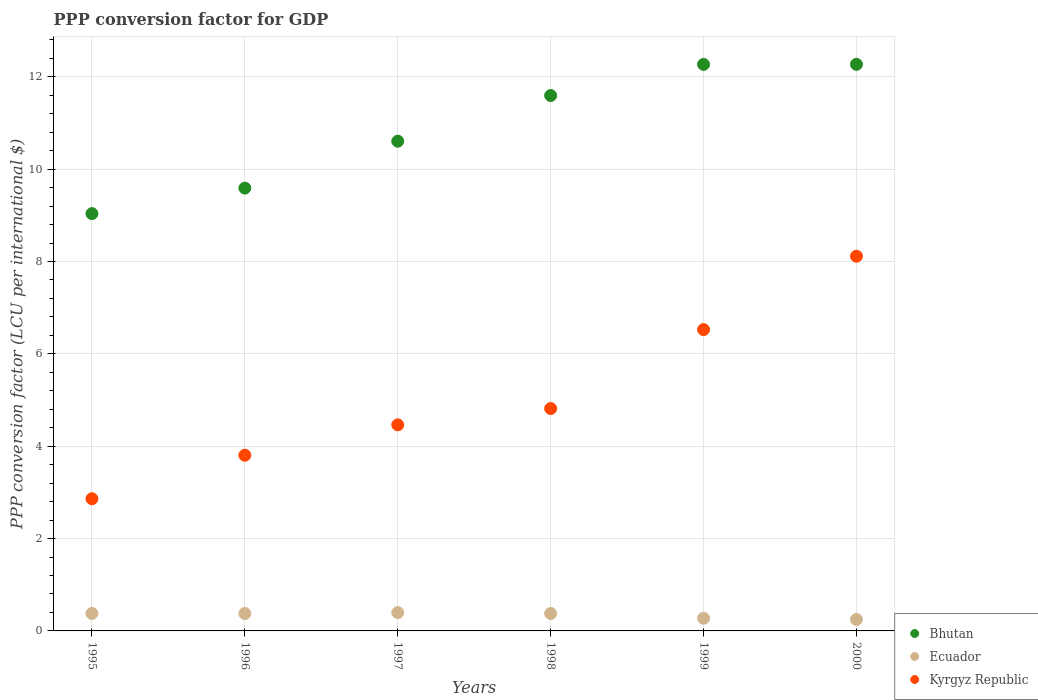What is the PPP conversion factor for GDP in Ecuador in 1999?
Provide a short and direct response. 0.27. Across all years, what is the maximum PPP conversion factor for GDP in Ecuador?
Provide a short and direct response. 0.4. Across all years, what is the minimum PPP conversion factor for GDP in Ecuador?
Ensure brevity in your answer.  0.25. What is the total PPP conversion factor for GDP in Ecuador in the graph?
Give a very brief answer. 2.05. What is the difference between the PPP conversion factor for GDP in Bhutan in 1996 and that in 2000?
Keep it short and to the point. -2.68. What is the difference between the PPP conversion factor for GDP in Kyrgyz Republic in 1995 and the PPP conversion factor for GDP in Ecuador in 1999?
Make the answer very short. 2.59. What is the average PPP conversion factor for GDP in Ecuador per year?
Your answer should be compact. 0.34. In the year 1996, what is the difference between the PPP conversion factor for GDP in Bhutan and PPP conversion factor for GDP in Ecuador?
Your answer should be compact. 9.21. What is the ratio of the PPP conversion factor for GDP in Ecuador in 1997 to that in 1998?
Provide a succinct answer. 1.05. Is the difference between the PPP conversion factor for GDP in Bhutan in 1999 and 2000 greater than the difference between the PPP conversion factor for GDP in Ecuador in 1999 and 2000?
Offer a terse response. No. What is the difference between the highest and the second highest PPP conversion factor for GDP in Ecuador?
Your response must be concise. 0.02. What is the difference between the highest and the lowest PPP conversion factor for GDP in Ecuador?
Your answer should be very brief. 0.15. Is the sum of the PPP conversion factor for GDP in Kyrgyz Republic in 1995 and 1996 greater than the maximum PPP conversion factor for GDP in Ecuador across all years?
Provide a succinct answer. Yes. Is it the case that in every year, the sum of the PPP conversion factor for GDP in Bhutan and PPP conversion factor for GDP in Ecuador  is greater than the PPP conversion factor for GDP in Kyrgyz Republic?
Offer a terse response. Yes. Does the PPP conversion factor for GDP in Ecuador monotonically increase over the years?
Your answer should be very brief. No. Is the PPP conversion factor for GDP in Bhutan strictly greater than the PPP conversion factor for GDP in Ecuador over the years?
Keep it short and to the point. Yes. Is the PPP conversion factor for GDP in Kyrgyz Republic strictly less than the PPP conversion factor for GDP in Ecuador over the years?
Give a very brief answer. No. How many dotlines are there?
Your answer should be very brief. 3. What is the difference between two consecutive major ticks on the Y-axis?
Keep it short and to the point. 2. Does the graph contain any zero values?
Provide a short and direct response. No. Where does the legend appear in the graph?
Provide a short and direct response. Bottom right. How many legend labels are there?
Ensure brevity in your answer.  3. How are the legend labels stacked?
Your response must be concise. Vertical. What is the title of the graph?
Provide a short and direct response. PPP conversion factor for GDP. What is the label or title of the Y-axis?
Provide a short and direct response. PPP conversion factor (LCU per international $). What is the PPP conversion factor (LCU per international $) of Bhutan in 1995?
Your answer should be very brief. 9.04. What is the PPP conversion factor (LCU per international $) of Ecuador in 1995?
Offer a very short reply. 0.38. What is the PPP conversion factor (LCU per international $) of Kyrgyz Republic in 1995?
Offer a very short reply. 2.86. What is the PPP conversion factor (LCU per international $) of Bhutan in 1996?
Make the answer very short. 9.59. What is the PPP conversion factor (LCU per international $) in Ecuador in 1996?
Provide a short and direct response. 0.38. What is the PPP conversion factor (LCU per international $) of Kyrgyz Republic in 1996?
Your answer should be compact. 3.8. What is the PPP conversion factor (LCU per international $) in Bhutan in 1997?
Make the answer very short. 10.61. What is the PPP conversion factor (LCU per international $) of Ecuador in 1997?
Keep it short and to the point. 0.4. What is the PPP conversion factor (LCU per international $) of Kyrgyz Republic in 1997?
Give a very brief answer. 4.46. What is the PPP conversion factor (LCU per international $) in Bhutan in 1998?
Keep it short and to the point. 11.59. What is the PPP conversion factor (LCU per international $) in Ecuador in 1998?
Offer a terse response. 0.38. What is the PPP conversion factor (LCU per international $) in Kyrgyz Republic in 1998?
Offer a very short reply. 4.82. What is the PPP conversion factor (LCU per international $) of Bhutan in 1999?
Offer a very short reply. 12.27. What is the PPP conversion factor (LCU per international $) of Ecuador in 1999?
Keep it short and to the point. 0.27. What is the PPP conversion factor (LCU per international $) of Kyrgyz Republic in 1999?
Provide a succinct answer. 6.53. What is the PPP conversion factor (LCU per international $) of Bhutan in 2000?
Offer a terse response. 12.27. What is the PPP conversion factor (LCU per international $) in Ecuador in 2000?
Give a very brief answer. 0.25. What is the PPP conversion factor (LCU per international $) in Kyrgyz Republic in 2000?
Keep it short and to the point. 8.11. Across all years, what is the maximum PPP conversion factor (LCU per international $) in Bhutan?
Provide a short and direct response. 12.27. Across all years, what is the maximum PPP conversion factor (LCU per international $) in Ecuador?
Your answer should be compact. 0.4. Across all years, what is the maximum PPP conversion factor (LCU per international $) of Kyrgyz Republic?
Keep it short and to the point. 8.11. Across all years, what is the minimum PPP conversion factor (LCU per international $) of Bhutan?
Provide a short and direct response. 9.04. Across all years, what is the minimum PPP conversion factor (LCU per international $) in Ecuador?
Make the answer very short. 0.25. Across all years, what is the minimum PPP conversion factor (LCU per international $) in Kyrgyz Republic?
Your answer should be very brief. 2.86. What is the total PPP conversion factor (LCU per international $) in Bhutan in the graph?
Your answer should be compact. 65.37. What is the total PPP conversion factor (LCU per international $) in Ecuador in the graph?
Give a very brief answer. 2.05. What is the total PPP conversion factor (LCU per international $) in Kyrgyz Republic in the graph?
Keep it short and to the point. 30.59. What is the difference between the PPP conversion factor (LCU per international $) in Bhutan in 1995 and that in 1996?
Provide a short and direct response. -0.55. What is the difference between the PPP conversion factor (LCU per international $) in Ecuador in 1995 and that in 1996?
Your answer should be very brief. 0. What is the difference between the PPP conversion factor (LCU per international $) in Kyrgyz Republic in 1995 and that in 1996?
Offer a very short reply. -0.94. What is the difference between the PPP conversion factor (LCU per international $) of Bhutan in 1995 and that in 1997?
Your answer should be compact. -1.57. What is the difference between the PPP conversion factor (LCU per international $) of Ecuador in 1995 and that in 1997?
Your answer should be very brief. -0.02. What is the difference between the PPP conversion factor (LCU per international $) in Kyrgyz Republic in 1995 and that in 1997?
Your answer should be compact. -1.6. What is the difference between the PPP conversion factor (LCU per international $) of Bhutan in 1995 and that in 1998?
Provide a succinct answer. -2.56. What is the difference between the PPP conversion factor (LCU per international $) of Ecuador in 1995 and that in 1998?
Provide a short and direct response. 0. What is the difference between the PPP conversion factor (LCU per international $) of Kyrgyz Republic in 1995 and that in 1998?
Give a very brief answer. -1.95. What is the difference between the PPP conversion factor (LCU per international $) of Bhutan in 1995 and that in 1999?
Your answer should be very brief. -3.23. What is the difference between the PPP conversion factor (LCU per international $) in Ecuador in 1995 and that in 1999?
Your response must be concise. 0.1. What is the difference between the PPP conversion factor (LCU per international $) of Kyrgyz Republic in 1995 and that in 1999?
Keep it short and to the point. -3.66. What is the difference between the PPP conversion factor (LCU per international $) of Bhutan in 1995 and that in 2000?
Your response must be concise. -3.23. What is the difference between the PPP conversion factor (LCU per international $) in Ecuador in 1995 and that in 2000?
Offer a terse response. 0.13. What is the difference between the PPP conversion factor (LCU per international $) in Kyrgyz Republic in 1995 and that in 2000?
Keep it short and to the point. -5.25. What is the difference between the PPP conversion factor (LCU per international $) in Bhutan in 1996 and that in 1997?
Keep it short and to the point. -1.02. What is the difference between the PPP conversion factor (LCU per international $) of Ecuador in 1996 and that in 1997?
Ensure brevity in your answer.  -0.02. What is the difference between the PPP conversion factor (LCU per international $) of Kyrgyz Republic in 1996 and that in 1997?
Provide a succinct answer. -0.66. What is the difference between the PPP conversion factor (LCU per international $) of Bhutan in 1996 and that in 1998?
Make the answer very short. -2. What is the difference between the PPP conversion factor (LCU per international $) in Ecuador in 1996 and that in 1998?
Your response must be concise. -0. What is the difference between the PPP conversion factor (LCU per international $) of Kyrgyz Republic in 1996 and that in 1998?
Make the answer very short. -1.01. What is the difference between the PPP conversion factor (LCU per international $) in Bhutan in 1996 and that in 1999?
Offer a terse response. -2.68. What is the difference between the PPP conversion factor (LCU per international $) of Ecuador in 1996 and that in 1999?
Provide a succinct answer. 0.1. What is the difference between the PPP conversion factor (LCU per international $) in Kyrgyz Republic in 1996 and that in 1999?
Provide a succinct answer. -2.72. What is the difference between the PPP conversion factor (LCU per international $) in Bhutan in 1996 and that in 2000?
Keep it short and to the point. -2.68. What is the difference between the PPP conversion factor (LCU per international $) of Ecuador in 1996 and that in 2000?
Keep it short and to the point. 0.13. What is the difference between the PPP conversion factor (LCU per international $) of Kyrgyz Republic in 1996 and that in 2000?
Give a very brief answer. -4.31. What is the difference between the PPP conversion factor (LCU per international $) in Bhutan in 1997 and that in 1998?
Provide a short and direct response. -0.99. What is the difference between the PPP conversion factor (LCU per international $) of Ecuador in 1997 and that in 1998?
Make the answer very short. 0.02. What is the difference between the PPP conversion factor (LCU per international $) of Kyrgyz Republic in 1997 and that in 1998?
Your answer should be very brief. -0.35. What is the difference between the PPP conversion factor (LCU per international $) in Bhutan in 1997 and that in 1999?
Keep it short and to the point. -1.66. What is the difference between the PPP conversion factor (LCU per international $) in Ecuador in 1997 and that in 1999?
Provide a short and direct response. 0.12. What is the difference between the PPP conversion factor (LCU per international $) in Kyrgyz Republic in 1997 and that in 1999?
Offer a terse response. -2.06. What is the difference between the PPP conversion factor (LCU per international $) in Bhutan in 1997 and that in 2000?
Ensure brevity in your answer.  -1.66. What is the difference between the PPP conversion factor (LCU per international $) in Ecuador in 1997 and that in 2000?
Offer a very short reply. 0.15. What is the difference between the PPP conversion factor (LCU per international $) in Kyrgyz Republic in 1997 and that in 2000?
Offer a very short reply. -3.65. What is the difference between the PPP conversion factor (LCU per international $) of Bhutan in 1998 and that in 1999?
Provide a short and direct response. -0.67. What is the difference between the PPP conversion factor (LCU per international $) in Ecuador in 1998 and that in 1999?
Give a very brief answer. 0.1. What is the difference between the PPP conversion factor (LCU per international $) of Kyrgyz Republic in 1998 and that in 1999?
Provide a short and direct response. -1.71. What is the difference between the PPP conversion factor (LCU per international $) in Bhutan in 1998 and that in 2000?
Provide a succinct answer. -0.68. What is the difference between the PPP conversion factor (LCU per international $) of Ecuador in 1998 and that in 2000?
Give a very brief answer. 0.13. What is the difference between the PPP conversion factor (LCU per international $) of Kyrgyz Republic in 1998 and that in 2000?
Give a very brief answer. -3.3. What is the difference between the PPP conversion factor (LCU per international $) in Bhutan in 1999 and that in 2000?
Your answer should be very brief. -0. What is the difference between the PPP conversion factor (LCU per international $) of Ecuador in 1999 and that in 2000?
Offer a very short reply. 0.03. What is the difference between the PPP conversion factor (LCU per international $) in Kyrgyz Republic in 1999 and that in 2000?
Keep it short and to the point. -1.59. What is the difference between the PPP conversion factor (LCU per international $) in Bhutan in 1995 and the PPP conversion factor (LCU per international $) in Ecuador in 1996?
Your answer should be compact. 8.66. What is the difference between the PPP conversion factor (LCU per international $) in Bhutan in 1995 and the PPP conversion factor (LCU per international $) in Kyrgyz Republic in 1996?
Ensure brevity in your answer.  5.23. What is the difference between the PPP conversion factor (LCU per international $) in Ecuador in 1995 and the PPP conversion factor (LCU per international $) in Kyrgyz Republic in 1996?
Your answer should be very brief. -3.43. What is the difference between the PPP conversion factor (LCU per international $) of Bhutan in 1995 and the PPP conversion factor (LCU per international $) of Ecuador in 1997?
Make the answer very short. 8.64. What is the difference between the PPP conversion factor (LCU per international $) of Bhutan in 1995 and the PPP conversion factor (LCU per international $) of Kyrgyz Republic in 1997?
Provide a short and direct response. 4.57. What is the difference between the PPP conversion factor (LCU per international $) in Ecuador in 1995 and the PPP conversion factor (LCU per international $) in Kyrgyz Republic in 1997?
Offer a terse response. -4.08. What is the difference between the PPP conversion factor (LCU per international $) of Bhutan in 1995 and the PPP conversion factor (LCU per international $) of Ecuador in 1998?
Your answer should be very brief. 8.66. What is the difference between the PPP conversion factor (LCU per international $) in Bhutan in 1995 and the PPP conversion factor (LCU per international $) in Kyrgyz Republic in 1998?
Your response must be concise. 4.22. What is the difference between the PPP conversion factor (LCU per international $) of Ecuador in 1995 and the PPP conversion factor (LCU per international $) of Kyrgyz Republic in 1998?
Offer a terse response. -4.44. What is the difference between the PPP conversion factor (LCU per international $) of Bhutan in 1995 and the PPP conversion factor (LCU per international $) of Ecuador in 1999?
Your answer should be compact. 8.76. What is the difference between the PPP conversion factor (LCU per international $) in Bhutan in 1995 and the PPP conversion factor (LCU per international $) in Kyrgyz Republic in 1999?
Offer a very short reply. 2.51. What is the difference between the PPP conversion factor (LCU per international $) in Ecuador in 1995 and the PPP conversion factor (LCU per international $) in Kyrgyz Republic in 1999?
Provide a succinct answer. -6.15. What is the difference between the PPP conversion factor (LCU per international $) in Bhutan in 1995 and the PPP conversion factor (LCU per international $) in Ecuador in 2000?
Give a very brief answer. 8.79. What is the difference between the PPP conversion factor (LCU per international $) of Bhutan in 1995 and the PPP conversion factor (LCU per international $) of Kyrgyz Republic in 2000?
Keep it short and to the point. 0.92. What is the difference between the PPP conversion factor (LCU per international $) in Ecuador in 1995 and the PPP conversion factor (LCU per international $) in Kyrgyz Republic in 2000?
Keep it short and to the point. -7.74. What is the difference between the PPP conversion factor (LCU per international $) of Bhutan in 1996 and the PPP conversion factor (LCU per international $) of Ecuador in 1997?
Ensure brevity in your answer.  9.19. What is the difference between the PPP conversion factor (LCU per international $) in Bhutan in 1996 and the PPP conversion factor (LCU per international $) in Kyrgyz Republic in 1997?
Your answer should be very brief. 5.13. What is the difference between the PPP conversion factor (LCU per international $) of Ecuador in 1996 and the PPP conversion factor (LCU per international $) of Kyrgyz Republic in 1997?
Make the answer very short. -4.09. What is the difference between the PPP conversion factor (LCU per international $) in Bhutan in 1996 and the PPP conversion factor (LCU per international $) in Ecuador in 1998?
Make the answer very short. 9.21. What is the difference between the PPP conversion factor (LCU per international $) in Bhutan in 1996 and the PPP conversion factor (LCU per international $) in Kyrgyz Republic in 1998?
Offer a terse response. 4.77. What is the difference between the PPP conversion factor (LCU per international $) of Ecuador in 1996 and the PPP conversion factor (LCU per international $) of Kyrgyz Republic in 1998?
Keep it short and to the point. -4.44. What is the difference between the PPP conversion factor (LCU per international $) of Bhutan in 1996 and the PPP conversion factor (LCU per international $) of Ecuador in 1999?
Provide a succinct answer. 9.32. What is the difference between the PPP conversion factor (LCU per international $) of Bhutan in 1996 and the PPP conversion factor (LCU per international $) of Kyrgyz Republic in 1999?
Provide a short and direct response. 3.06. What is the difference between the PPP conversion factor (LCU per international $) of Ecuador in 1996 and the PPP conversion factor (LCU per international $) of Kyrgyz Republic in 1999?
Provide a short and direct response. -6.15. What is the difference between the PPP conversion factor (LCU per international $) in Bhutan in 1996 and the PPP conversion factor (LCU per international $) in Ecuador in 2000?
Make the answer very short. 9.34. What is the difference between the PPP conversion factor (LCU per international $) of Bhutan in 1996 and the PPP conversion factor (LCU per international $) of Kyrgyz Republic in 2000?
Your answer should be compact. 1.48. What is the difference between the PPP conversion factor (LCU per international $) of Ecuador in 1996 and the PPP conversion factor (LCU per international $) of Kyrgyz Republic in 2000?
Ensure brevity in your answer.  -7.74. What is the difference between the PPP conversion factor (LCU per international $) in Bhutan in 1997 and the PPP conversion factor (LCU per international $) in Ecuador in 1998?
Offer a terse response. 10.23. What is the difference between the PPP conversion factor (LCU per international $) in Bhutan in 1997 and the PPP conversion factor (LCU per international $) in Kyrgyz Republic in 1998?
Your answer should be compact. 5.79. What is the difference between the PPP conversion factor (LCU per international $) of Ecuador in 1997 and the PPP conversion factor (LCU per international $) of Kyrgyz Republic in 1998?
Offer a very short reply. -4.42. What is the difference between the PPP conversion factor (LCU per international $) of Bhutan in 1997 and the PPP conversion factor (LCU per international $) of Ecuador in 1999?
Your response must be concise. 10.33. What is the difference between the PPP conversion factor (LCU per international $) in Bhutan in 1997 and the PPP conversion factor (LCU per international $) in Kyrgyz Republic in 1999?
Give a very brief answer. 4.08. What is the difference between the PPP conversion factor (LCU per international $) of Ecuador in 1997 and the PPP conversion factor (LCU per international $) of Kyrgyz Republic in 1999?
Your response must be concise. -6.13. What is the difference between the PPP conversion factor (LCU per international $) of Bhutan in 1997 and the PPP conversion factor (LCU per international $) of Ecuador in 2000?
Offer a terse response. 10.36. What is the difference between the PPP conversion factor (LCU per international $) in Bhutan in 1997 and the PPP conversion factor (LCU per international $) in Kyrgyz Republic in 2000?
Your answer should be very brief. 2.49. What is the difference between the PPP conversion factor (LCU per international $) in Ecuador in 1997 and the PPP conversion factor (LCU per international $) in Kyrgyz Republic in 2000?
Make the answer very short. -7.72. What is the difference between the PPP conversion factor (LCU per international $) in Bhutan in 1998 and the PPP conversion factor (LCU per international $) in Ecuador in 1999?
Offer a very short reply. 11.32. What is the difference between the PPP conversion factor (LCU per international $) in Bhutan in 1998 and the PPP conversion factor (LCU per international $) in Kyrgyz Republic in 1999?
Make the answer very short. 5.07. What is the difference between the PPP conversion factor (LCU per international $) of Ecuador in 1998 and the PPP conversion factor (LCU per international $) of Kyrgyz Republic in 1999?
Your answer should be very brief. -6.15. What is the difference between the PPP conversion factor (LCU per international $) in Bhutan in 1998 and the PPP conversion factor (LCU per international $) in Ecuador in 2000?
Provide a succinct answer. 11.35. What is the difference between the PPP conversion factor (LCU per international $) of Bhutan in 1998 and the PPP conversion factor (LCU per international $) of Kyrgyz Republic in 2000?
Provide a succinct answer. 3.48. What is the difference between the PPP conversion factor (LCU per international $) of Ecuador in 1998 and the PPP conversion factor (LCU per international $) of Kyrgyz Republic in 2000?
Your answer should be compact. -7.74. What is the difference between the PPP conversion factor (LCU per international $) of Bhutan in 1999 and the PPP conversion factor (LCU per international $) of Ecuador in 2000?
Your response must be concise. 12.02. What is the difference between the PPP conversion factor (LCU per international $) in Bhutan in 1999 and the PPP conversion factor (LCU per international $) in Kyrgyz Republic in 2000?
Keep it short and to the point. 4.15. What is the difference between the PPP conversion factor (LCU per international $) in Ecuador in 1999 and the PPP conversion factor (LCU per international $) in Kyrgyz Republic in 2000?
Your answer should be very brief. -7.84. What is the average PPP conversion factor (LCU per international $) of Bhutan per year?
Your answer should be compact. 10.89. What is the average PPP conversion factor (LCU per international $) of Ecuador per year?
Your answer should be very brief. 0.34. What is the average PPP conversion factor (LCU per international $) of Kyrgyz Republic per year?
Offer a terse response. 5.1. In the year 1995, what is the difference between the PPP conversion factor (LCU per international $) in Bhutan and PPP conversion factor (LCU per international $) in Ecuador?
Keep it short and to the point. 8.66. In the year 1995, what is the difference between the PPP conversion factor (LCU per international $) of Bhutan and PPP conversion factor (LCU per international $) of Kyrgyz Republic?
Make the answer very short. 6.17. In the year 1995, what is the difference between the PPP conversion factor (LCU per international $) of Ecuador and PPP conversion factor (LCU per international $) of Kyrgyz Republic?
Give a very brief answer. -2.48. In the year 1996, what is the difference between the PPP conversion factor (LCU per international $) of Bhutan and PPP conversion factor (LCU per international $) of Ecuador?
Your response must be concise. 9.21. In the year 1996, what is the difference between the PPP conversion factor (LCU per international $) of Bhutan and PPP conversion factor (LCU per international $) of Kyrgyz Republic?
Provide a succinct answer. 5.79. In the year 1996, what is the difference between the PPP conversion factor (LCU per international $) in Ecuador and PPP conversion factor (LCU per international $) in Kyrgyz Republic?
Your answer should be very brief. -3.43. In the year 1997, what is the difference between the PPP conversion factor (LCU per international $) of Bhutan and PPP conversion factor (LCU per international $) of Ecuador?
Keep it short and to the point. 10.21. In the year 1997, what is the difference between the PPP conversion factor (LCU per international $) in Bhutan and PPP conversion factor (LCU per international $) in Kyrgyz Republic?
Ensure brevity in your answer.  6.14. In the year 1997, what is the difference between the PPP conversion factor (LCU per international $) in Ecuador and PPP conversion factor (LCU per international $) in Kyrgyz Republic?
Offer a very short reply. -4.07. In the year 1998, what is the difference between the PPP conversion factor (LCU per international $) of Bhutan and PPP conversion factor (LCU per international $) of Ecuador?
Make the answer very short. 11.22. In the year 1998, what is the difference between the PPP conversion factor (LCU per international $) of Bhutan and PPP conversion factor (LCU per international $) of Kyrgyz Republic?
Offer a very short reply. 6.78. In the year 1998, what is the difference between the PPP conversion factor (LCU per international $) of Ecuador and PPP conversion factor (LCU per international $) of Kyrgyz Republic?
Make the answer very short. -4.44. In the year 1999, what is the difference between the PPP conversion factor (LCU per international $) of Bhutan and PPP conversion factor (LCU per international $) of Ecuador?
Your answer should be compact. 11.99. In the year 1999, what is the difference between the PPP conversion factor (LCU per international $) of Bhutan and PPP conversion factor (LCU per international $) of Kyrgyz Republic?
Make the answer very short. 5.74. In the year 1999, what is the difference between the PPP conversion factor (LCU per international $) of Ecuador and PPP conversion factor (LCU per international $) of Kyrgyz Republic?
Keep it short and to the point. -6.25. In the year 2000, what is the difference between the PPP conversion factor (LCU per international $) of Bhutan and PPP conversion factor (LCU per international $) of Ecuador?
Your answer should be very brief. 12.02. In the year 2000, what is the difference between the PPP conversion factor (LCU per international $) of Bhutan and PPP conversion factor (LCU per international $) of Kyrgyz Republic?
Ensure brevity in your answer.  4.16. In the year 2000, what is the difference between the PPP conversion factor (LCU per international $) of Ecuador and PPP conversion factor (LCU per international $) of Kyrgyz Republic?
Make the answer very short. -7.87. What is the ratio of the PPP conversion factor (LCU per international $) of Bhutan in 1995 to that in 1996?
Ensure brevity in your answer.  0.94. What is the ratio of the PPP conversion factor (LCU per international $) in Kyrgyz Republic in 1995 to that in 1996?
Provide a short and direct response. 0.75. What is the ratio of the PPP conversion factor (LCU per international $) in Bhutan in 1995 to that in 1997?
Give a very brief answer. 0.85. What is the ratio of the PPP conversion factor (LCU per international $) in Ecuador in 1995 to that in 1997?
Ensure brevity in your answer.  0.95. What is the ratio of the PPP conversion factor (LCU per international $) of Kyrgyz Republic in 1995 to that in 1997?
Provide a short and direct response. 0.64. What is the ratio of the PPP conversion factor (LCU per international $) in Bhutan in 1995 to that in 1998?
Provide a short and direct response. 0.78. What is the ratio of the PPP conversion factor (LCU per international $) of Ecuador in 1995 to that in 1998?
Your answer should be very brief. 1. What is the ratio of the PPP conversion factor (LCU per international $) of Kyrgyz Republic in 1995 to that in 1998?
Your answer should be compact. 0.59. What is the ratio of the PPP conversion factor (LCU per international $) in Bhutan in 1995 to that in 1999?
Offer a terse response. 0.74. What is the ratio of the PPP conversion factor (LCU per international $) in Ecuador in 1995 to that in 1999?
Your answer should be very brief. 1.38. What is the ratio of the PPP conversion factor (LCU per international $) in Kyrgyz Republic in 1995 to that in 1999?
Your response must be concise. 0.44. What is the ratio of the PPP conversion factor (LCU per international $) in Bhutan in 1995 to that in 2000?
Your answer should be very brief. 0.74. What is the ratio of the PPP conversion factor (LCU per international $) of Ecuador in 1995 to that in 2000?
Offer a very short reply. 1.53. What is the ratio of the PPP conversion factor (LCU per international $) in Kyrgyz Republic in 1995 to that in 2000?
Make the answer very short. 0.35. What is the ratio of the PPP conversion factor (LCU per international $) in Bhutan in 1996 to that in 1997?
Your answer should be very brief. 0.9. What is the ratio of the PPP conversion factor (LCU per international $) in Ecuador in 1996 to that in 1997?
Your response must be concise. 0.95. What is the ratio of the PPP conversion factor (LCU per international $) in Kyrgyz Republic in 1996 to that in 1997?
Provide a short and direct response. 0.85. What is the ratio of the PPP conversion factor (LCU per international $) in Bhutan in 1996 to that in 1998?
Offer a very short reply. 0.83. What is the ratio of the PPP conversion factor (LCU per international $) of Ecuador in 1996 to that in 1998?
Keep it short and to the point. 1. What is the ratio of the PPP conversion factor (LCU per international $) of Kyrgyz Republic in 1996 to that in 1998?
Your answer should be very brief. 0.79. What is the ratio of the PPP conversion factor (LCU per international $) in Bhutan in 1996 to that in 1999?
Provide a short and direct response. 0.78. What is the ratio of the PPP conversion factor (LCU per international $) of Ecuador in 1996 to that in 1999?
Your answer should be compact. 1.38. What is the ratio of the PPP conversion factor (LCU per international $) of Kyrgyz Republic in 1996 to that in 1999?
Your response must be concise. 0.58. What is the ratio of the PPP conversion factor (LCU per international $) of Bhutan in 1996 to that in 2000?
Give a very brief answer. 0.78. What is the ratio of the PPP conversion factor (LCU per international $) in Ecuador in 1996 to that in 2000?
Give a very brief answer. 1.52. What is the ratio of the PPP conversion factor (LCU per international $) of Kyrgyz Republic in 1996 to that in 2000?
Your answer should be very brief. 0.47. What is the ratio of the PPP conversion factor (LCU per international $) in Bhutan in 1997 to that in 1998?
Your response must be concise. 0.91. What is the ratio of the PPP conversion factor (LCU per international $) in Ecuador in 1997 to that in 1998?
Your response must be concise. 1.05. What is the ratio of the PPP conversion factor (LCU per international $) in Kyrgyz Republic in 1997 to that in 1998?
Ensure brevity in your answer.  0.93. What is the ratio of the PPP conversion factor (LCU per international $) of Bhutan in 1997 to that in 1999?
Keep it short and to the point. 0.86. What is the ratio of the PPP conversion factor (LCU per international $) in Ecuador in 1997 to that in 1999?
Your answer should be compact. 1.45. What is the ratio of the PPP conversion factor (LCU per international $) of Kyrgyz Republic in 1997 to that in 1999?
Provide a succinct answer. 0.68. What is the ratio of the PPP conversion factor (LCU per international $) in Bhutan in 1997 to that in 2000?
Your answer should be compact. 0.86. What is the ratio of the PPP conversion factor (LCU per international $) of Ecuador in 1997 to that in 2000?
Make the answer very short. 1.6. What is the ratio of the PPP conversion factor (LCU per international $) in Kyrgyz Republic in 1997 to that in 2000?
Offer a terse response. 0.55. What is the ratio of the PPP conversion factor (LCU per international $) of Bhutan in 1998 to that in 1999?
Offer a terse response. 0.94. What is the ratio of the PPP conversion factor (LCU per international $) of Ecuador in 1998 to that in 1999?
Offer a terse response. 1.38. What is the ratio of the PPP conversion factor (LCU per international $) of Kyrgyz Republic in 1998 to that in 1999?
Offer a very short reply. 0.74. What is the ratio of the PPP conversion factor (LCU per international $) in Bhutan in 1998 to that in 2000?
Your response must be concise. 0.94. What is the ratio of the PPP conversion factor (LCU per international $) in Ecuador in 1998 to that in 2000?
Give a very brief answer. 1.53. What is the ratio of the PPP conversion factor (LCU per international $) in Kyrgyz Republic in 1998 to that in 2000?
Keep it short and to the point. 0.59. What is the ratio of the PPP conversion factor (LCU per international $) of Bhutan in 1999 to that in 2000?
Provide a succinct answer. 1. What is the ratio of the PPP conversion factor (LCU per international $) of Ecuador in 1999 to that in 2000?
Your response must be concise. 1.11. What is the ratio of the PPP conversion factor (LCU per international $) of Kyrgyz Republic in 1999 to that in 2000?
Your response must be concise. 0.8. What is the difference between the highest and the second highest PPP conversion factor (LCU per international $) of Bhutan?
Ensure brevity in your answer.  0. What is the difference between the highest and the second highest PPP conversion factor (LCU per international $) in Ecuador?
Provide a succinct answer. 0.02. What is the difference between the highest and the second highest PPP conversion factor (LCU per international $) in Kyrgyz Republic?
Ensure brevity in your answer.  1.59. What is the difference between the highest and the lowest PPP conversion factor (LCU per international $) of Bhutan?
Your response must be concise. 3.23. What is the difference between the highest and the lowest PPP conversion factor (LCU per international $) of Ecuador?
Your answer should be compact. 0.15. What is the difference between the highest and the lowest PPP conversion factor (LCU per international $) of Kyrgyz Republic?
Give a very brief answer. 5.25. 